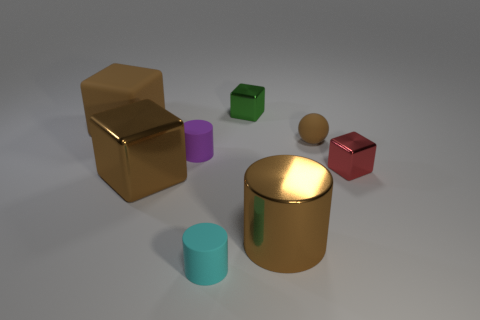How many other things are the same shape as the big rubber object?
Provide a succinct answer. 3. Are there any tiny cylinders made of the same material as the red block?
Your answer should be very brief. No. Are the brown thing that is behind the rubber ball and the big thing that is right of the large metal cube made of the same material?
Your answer should be compact. No. What number of red shiny objects are there?
Provide a succinct answer. 1. What is the shape of the large brown metal object that is to the left of the green object?
Make the answer very short. Cube. How many other things are there of the same size as the brown metal cylinder?
Ensure brevity in your answer.  2. Is the shape of the thing that is left of the large brown metallic cube the same as the large brown thing to the right of the purple rubber cylinder?
Keep it short and to the point. No. How many shiny blocks are right of the cyan matte thing?
Keep it short and to the point. 2. What is the color of the tiny matte sphere that is in front of the small green thing?
Provide a succinct answer. Brown. What color is the large thing that is the same shape as the small purple object?
Your answer should be compact. Brown. 